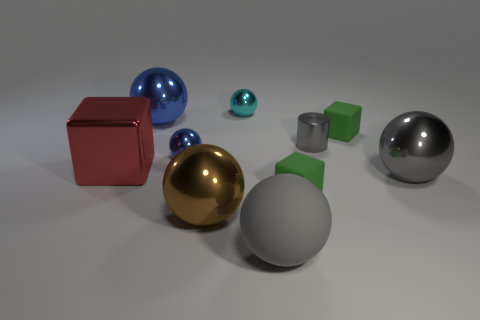Subtract all gray spheres. How many spheres are left? 4 Subtract all big gray metallic balls. How many balls are left? 5 Subtract 4 spheres. How many spheres are left? 2 Subtract all purple balls. Subtract all red cylinders. How many balls are left? 6 Subtract all cylinders. How many objects are left? 9 Subtract all red objects. Subtract all gray shiny balls. How many objects are left? 8 Add 1 big shiny cubes. How many big shiny cubes are left? 2 Add 7 tiny green blocks. How many tiny green blocks exist? 9 Subtract 0 purple balls. How many objects are left? 10 